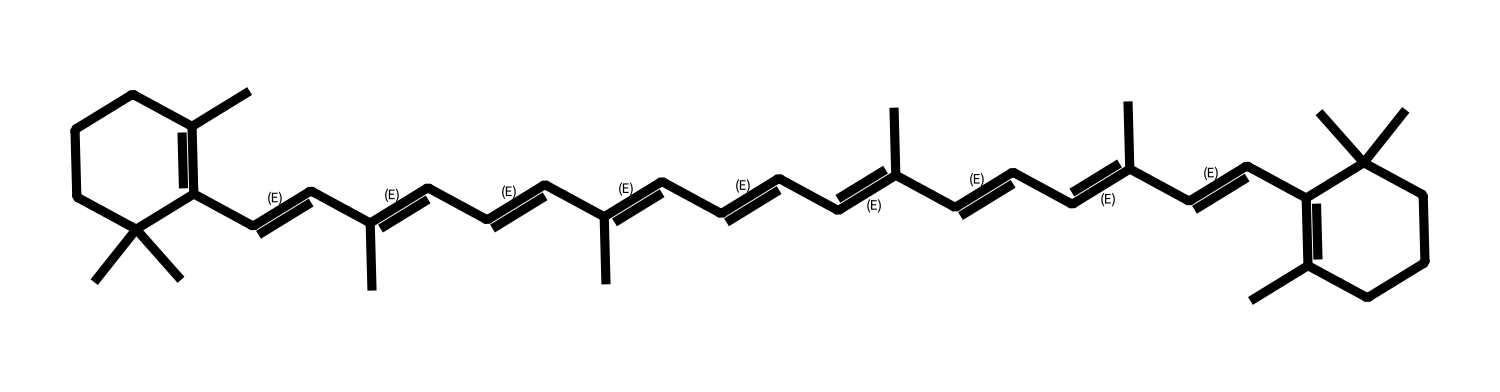What is the primary function of beta-carotene in algae? Beta-carotene primarily serves as a pigment that helps in photosynthesis by capturing light energy. It is also an antioxidant that protects the organism from oxidative stress.
Answer: antioxidant How many double bonds are present in beta-carotene? By examining the structure, you can count a total of eleven double bonds in the long carbon chain, which is critical to its function as an antioxidant.
Answer: eleven What is the chemical class of beta-carotene? Beta-carotene belongs to the class of compounds known as carotenoids, which are important pigments found in many plants and algae.
Answer: carotenoid How many carbon atoms are in beta-carotene? In the provided SMILES representation, the total number of carbon atoms is calculated to be 40, which is characteristic of its structure.
Answer: 40 What is the role of beta-carotene in human health? Beta-carotene is converted into vitamin A in the body, which is essential for vision, immunity, and skin health.
Answer: vitamin A Which part of the beta-carotene structure is responsible for its antioxidant properties? The long chain of conjugated double bonds in beta-carotene provides stability to free radicals, allowing it to act effectively as an antioxidant.
Answer: conjugated double bonds 